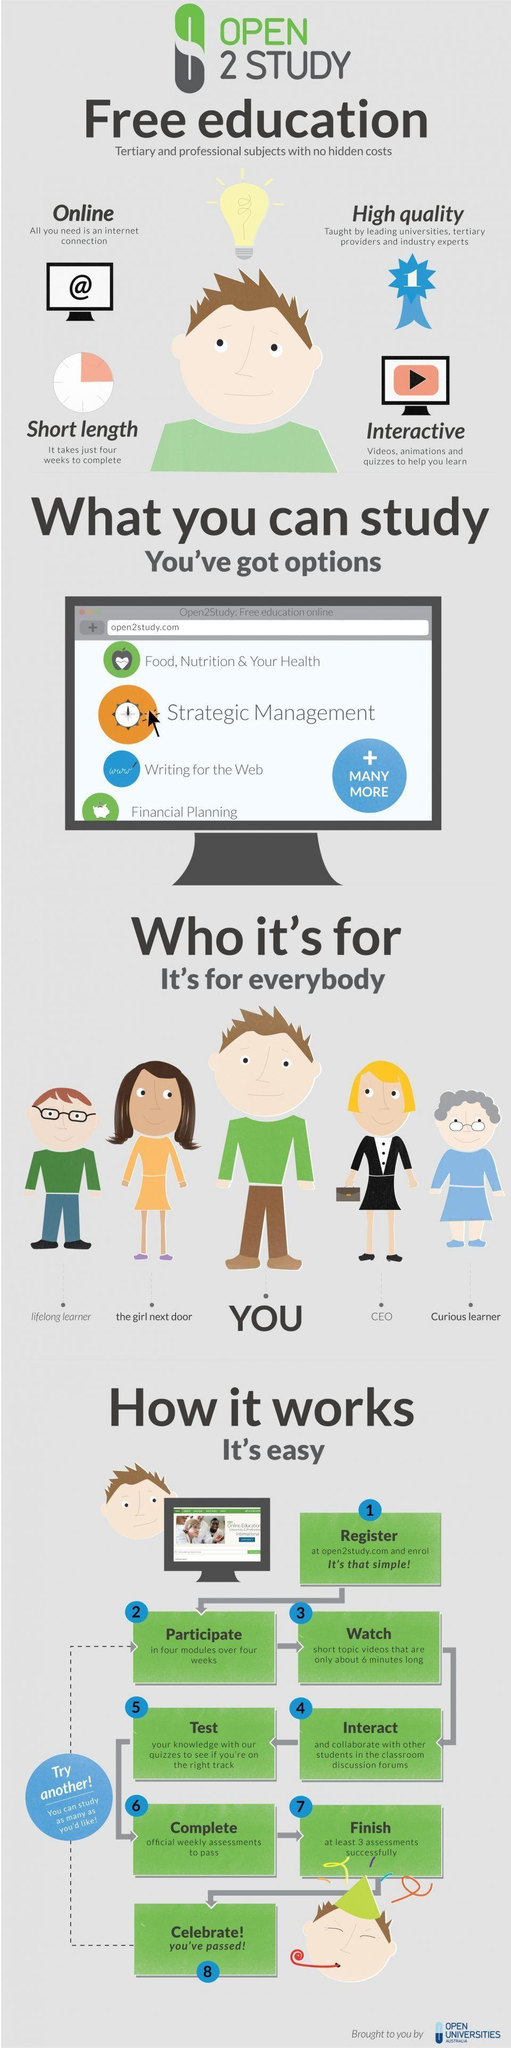How many study options are shown on the computer screen?
Answer the question with a short phrase. 4 